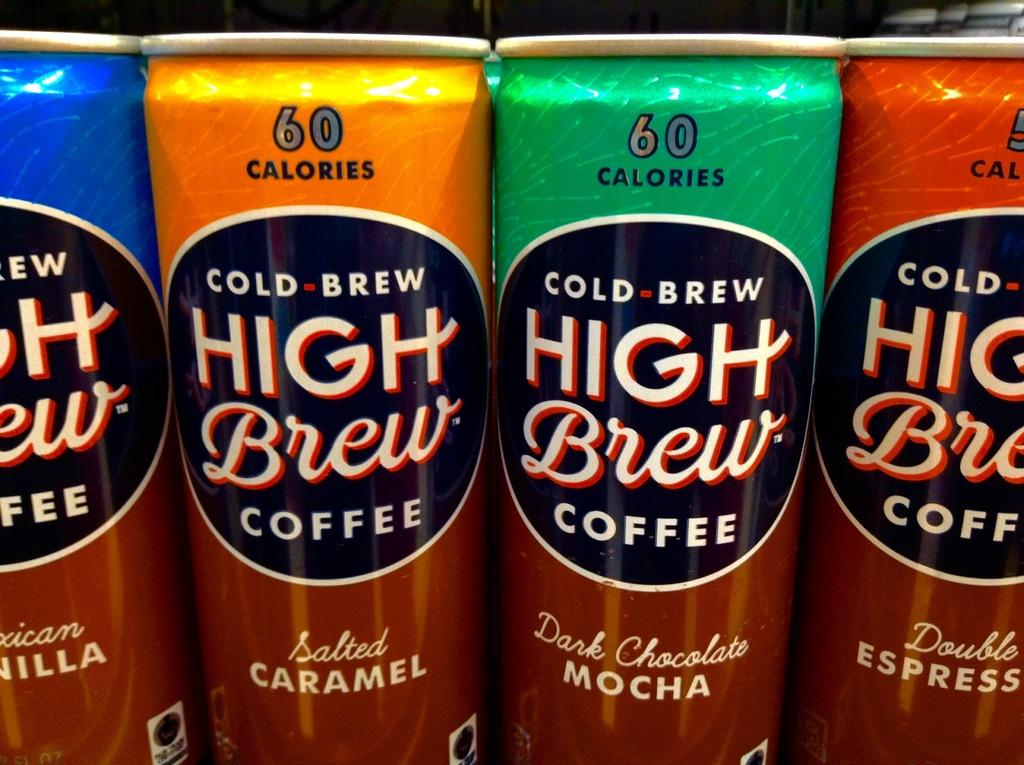<image>
Summarize the visual content of the image. A close up of four cans of low calorie coffee of various flavours. 